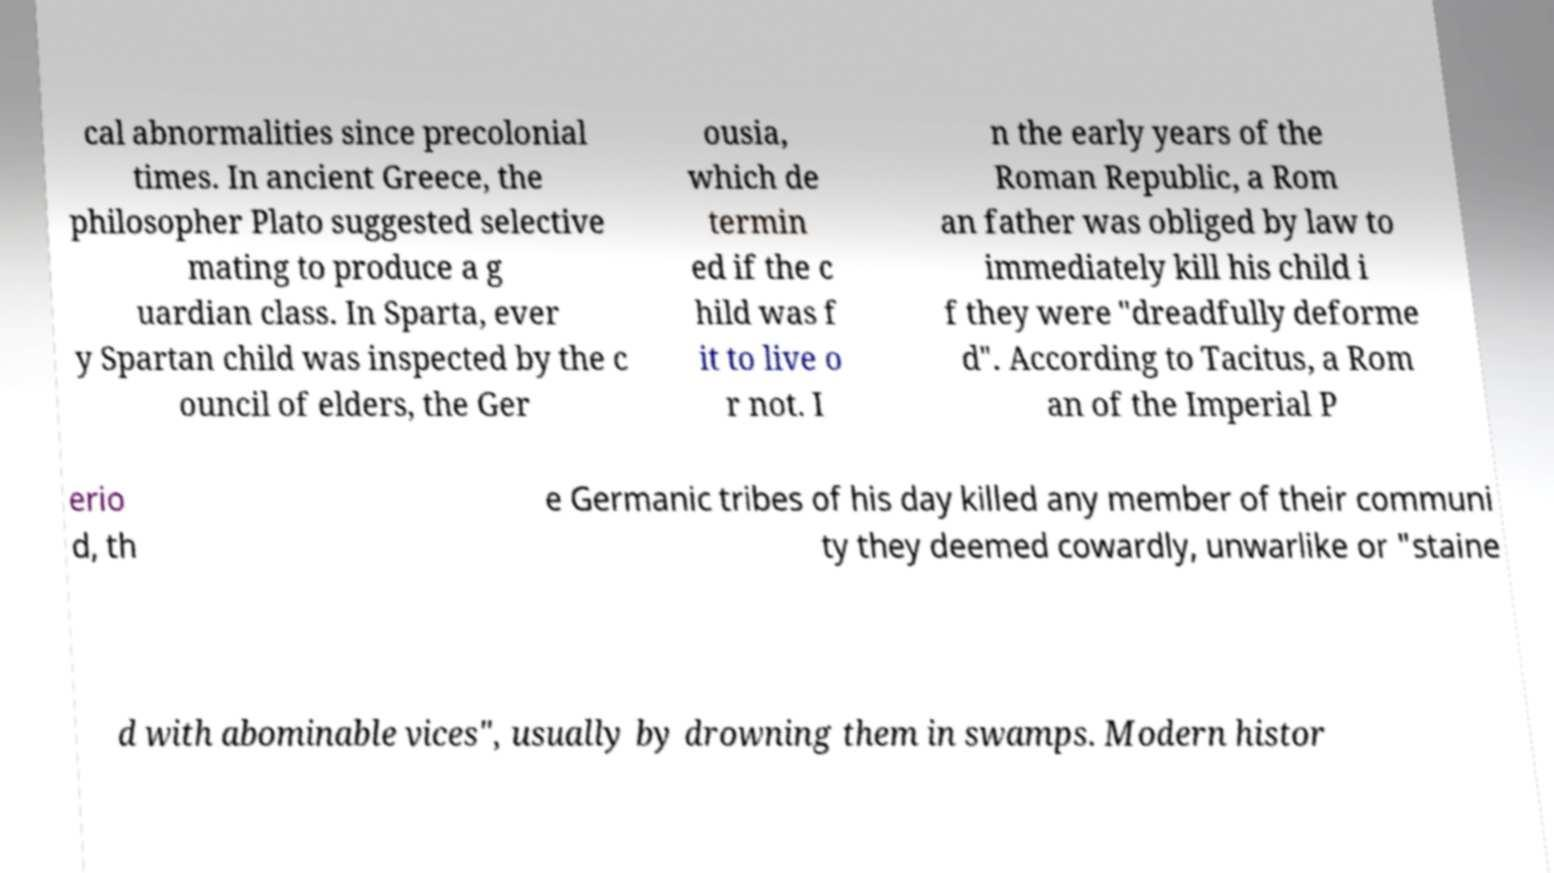Can you accurately transcribe the text from the provided image for me? cal abnormalities since precolonial times. In ancient Greece, the philosopher Plato suggested selective mating to produce a g uardian class. In Sparta, ever y Spartan child was inspected by the c ouncil of elders, the Ger ousia, which de termin ed if the c hild was f it to live o r not. I n the early years of the Roman Republic, a Rom an father was obliged by law to immediately kill his child i f they were "dreadfully deforme d". According to Tacitus, a Rom an of the Imperial P erio d, th e Germanic tribes of his day killed any member of their communi ty they deemed cowardly, unwarlike or "staine d with abominable vices", usually by drowning them in swamps. Modern histor 